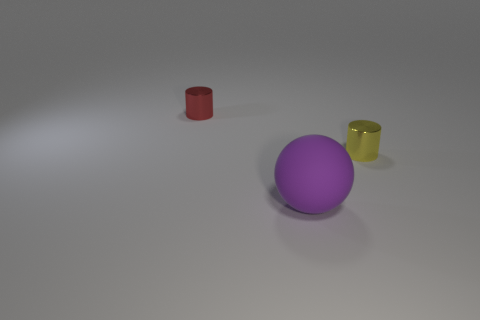What number of large objects are either yellow cubes or yellow metallic objects?
Offer a very short reply. 0. Do the small object that is to the left of the purple rubber object and the yellow cylinder have the same material?
Provide a succinct answer. Yes. There is a cylinder that is in front of the tiny cylinder to the left of the big purple object that is in front of the red shiny cylinder; what is it made of?
Your answer should be very brief. Metal. Is there anything else that has the same size as the ball?
Offer a terse response. No. How many metallic things are either gray cubes or small things?
Provide a succinct answer. 2. Is there a tiny brown matte cylinder?
Your answer should be compact. No. There is a metal cylinder that is on the left side of the big rubber ball in front of the tiny red metal cylinder; what is its color?
Make the answer very short. Red. What number of other objects are there of the same color as the big rubber object?
Provide a succinct answer. 0. How many objects are big cyan metallic cubes or metal things to the left of the purple object?
Ensure brevity in your answer.  1. There is a cylinder that is in front of the red thing; what color is it?
Your answer should be compact. Yellow. 